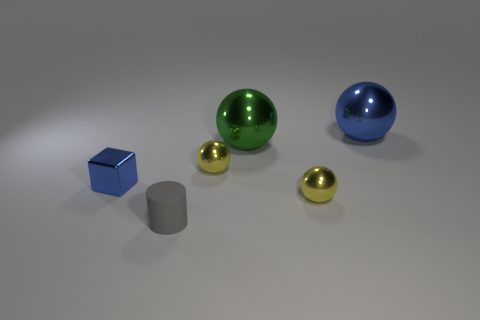There is a big object that is the same color as the tiny shiny block; what shape is it?
Your response must be concise. Sphere. Is there anything else that has the same material as the green sphere?
Your response must be concise. Yes. What number of things are gray rubber objects or objects behind the small rubber cylinder?
Offer a very short reply. 6. There is a object that is right of the green shiny thing and in front of the big blue shiny ball; what size is it?
Provide a succinct answer. Small. Is the number of tiny blue things that are in front of the small blue metal object greater than the number of tiny yellow metallic objects that are on the left side of the green object?
Ensure brevity in your answer.  No. Do the large green object and the blue thing that is to the left of the blue ball have the same shape?
Provide a succinct answer. No. How many other objects are the same shape as the tiny rubber object?
Your answer should be very brief. 0. What color is the small object that is in front of the small blue object and behind the small gray matte object?
Offer a terse response. Yellow. The small metallic cube has what color?
Ensure brevity in your answer.  Blue. Are the green sphere and the tiny yellow sphere to the left of the green ball made of the same material?
Your response must be concise. Yes. 